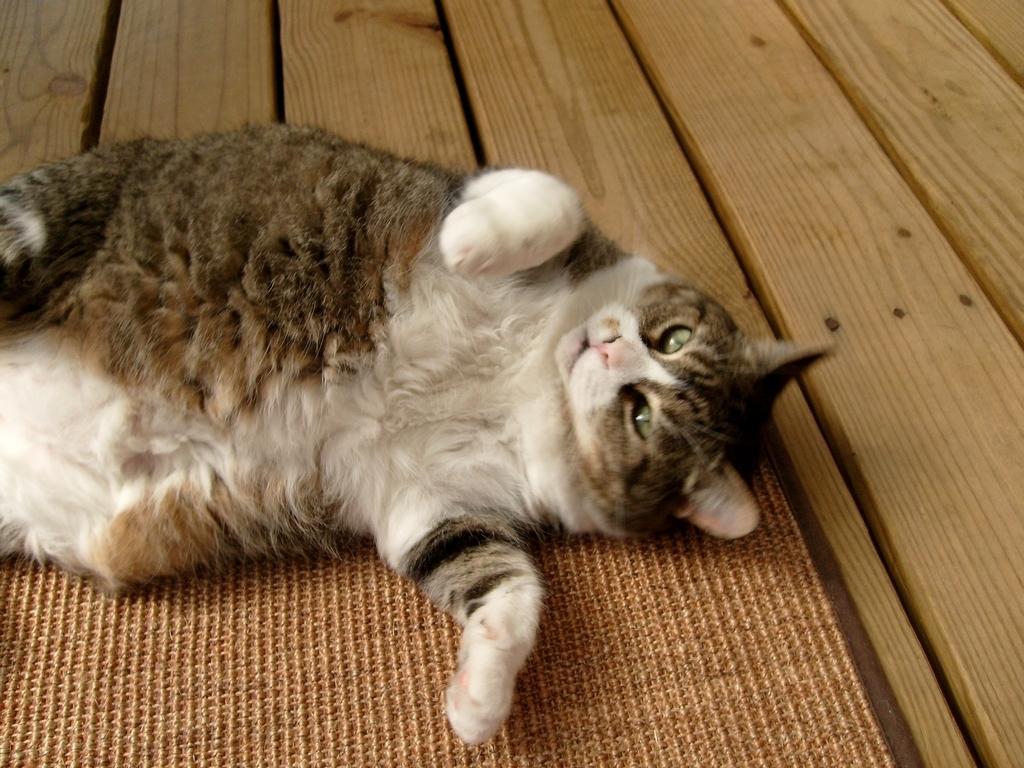Can you describe this image briefly? Here there is a cat, this is wooden object. 